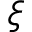Convert formula to latex. <formula><loc_0><loc_0><loc_500><loc_500>\xi</formula> 